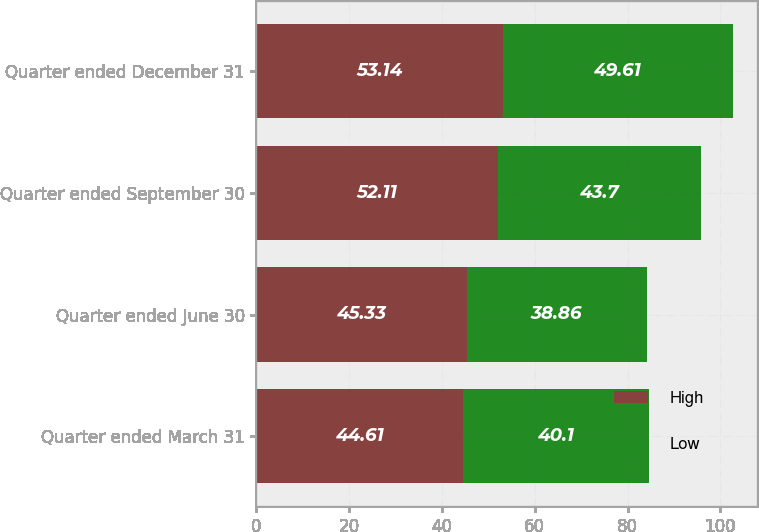Convert chart to OTSL. <chart><loc_0><loc_0><loc_500><loc_500><stacked_bar_chart><ecel><fcel>Quarter ended March 31<fcel>Quarter ended June 30<fcel>Quarter ended September 30<fcel>Quarter ended December 31<nl><fcel>High<fcel>44.61<fcel>45.33<fcel>52.11<fcel>53.14<nl><fcel>Low<fcel>40.1<fcel>38.86<fcel>43.7<fcel>49.61<nl></chart> 